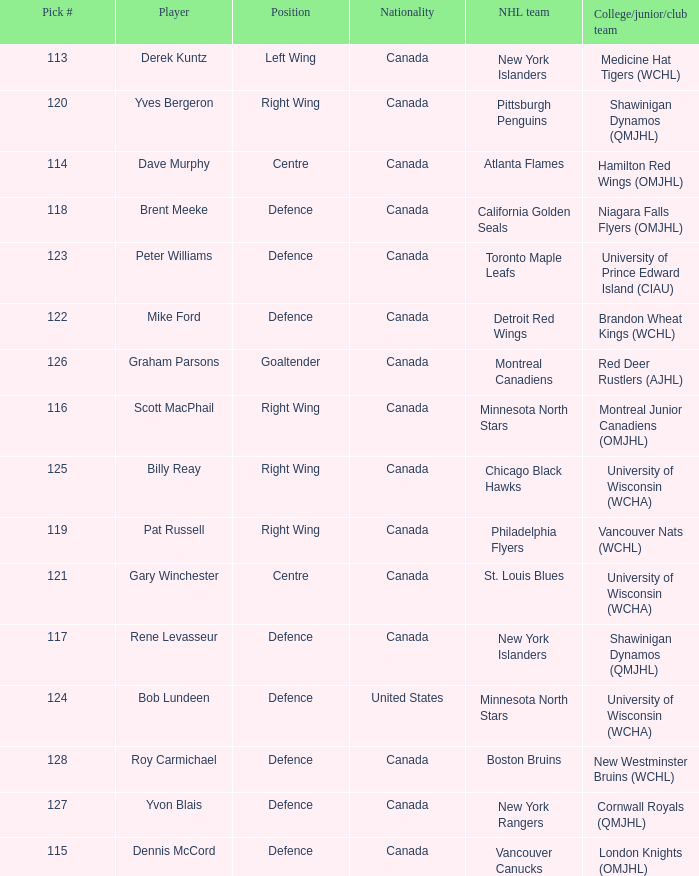Name the position for pick number 128 Defence. 